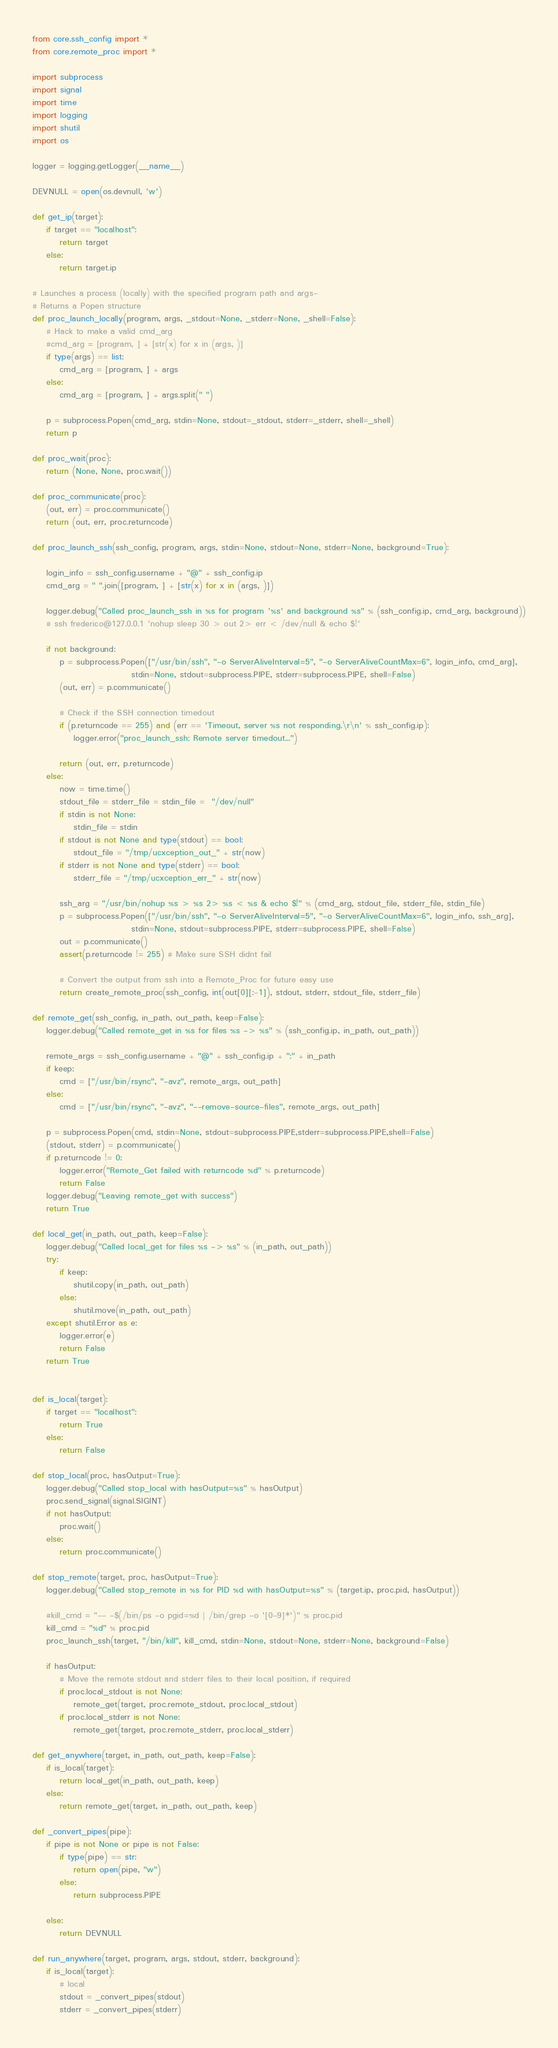Convert code to text. <code><loc_0><loc_0><loc_500><loc_500><_Python_>from core.ssh_config import *
from core.remote_proc import *

import subprocess
import signal
import time
import logging
import shutil
import os

logger = logging.getLogger(__name__)

DEVNULL = open(os.devnull, 'w')

def get_ip(target):
	if target == "localhost":
		return target
	else:
		return target.ip

# Launches a process (locally) with the specified program path and args-
# Returns a Popen structure
def proc_launch_locally(program, args, _stdout=None, _stderr=None, _shell=False):
	# Hack to make a valid cmd_arg
	#cmd_arg = [program, ] + [str(x) for x in (args, )]
	if type(args) == list:
		cmd_arg = [program, ] + args
	else:
		cmd_arg = [program, ] + args.split(" ")

	p = subprocess.Popen(cmd_arg, stdin=None, stdout=_stdout, stderr=_stderr, shell=_shell)
	return p

def proc_wait(proc):
	return (None, None, proc.wait())

def proc_communicate(proc):
	(out, err) = proc.communicate()
	return (out, err, proc.returncode)

def proc_launch_ssh(ssh_config, program, args, stdin=None, stdout=None, stderr=None, background=True):

	login_info = ssh_config.username + "@" + ssh_config.ip 
	cmd_arg = " ".join([program, ] + [str(x) for x in (args, )])
	
	logger.debug("Called proc_launch_ssh in %s for program '%s' and background %s" % (ssh_config.ip, cmd_arg, background))
	# ssh frederico@127.0.0.1 'nohup sleep 30 > out 2> err < /dev/null & echo $!'

	if not background:
		p = subprocess.Popen(["/usr/bin/ssh", "-o ServerAliveInterval=5", "-o ServerAliveCountMax=6", login_info, cmd_arg],
							 stdin=None, stdout=subprocess.PIPE, stderr=subprocess.PIPE, shell=False)
		(out, err) = p.communicate()

		# Check if the SSH connection timedout
		if (p.returncode == 255) and (err == 'Timeout, server %s not responding.\r\n' % ssh_config.ip):
			logger.error("proc_launch_ssh: Remote server timedout...")

		return (out, err, p.returncode)
	else:
		now = time.time()
		stdout_file = stderr_file = stdin_file =  "/dev/null"
		if stdin is not None:
			stdin_file = stdin
		if stdout is not None and type(stdout) == bool:
			stdout_file = "/tmp/ucxception_out_" + str(now)
		if stderr is not None and type(stderr) == bool:
			stderr_file = "/tmp/ucxception_err_" + str(now)

		ssh_arg = "/usr/bin/nohup %s > %s 2> %s < %s & echo $!" % (cmd_arg, stdout_file, stderr_file, stdin_file)
		p = subprocess.Popen(["/usr/bin/ssh", "-o ServerAliveInterval=5", "-o ServerAliveCountMax=6", login_info, ssh_arg],
							 stdin=None, stdout=subprocess.PIPE, stderr=subprocess.PIPE, shell=False)
		out = p.communicate()
		assert(p.returncode != 255) # Make sure SSH didnt fail

		# Convert the output from ssh into a Remote_Proc for future easy use
		return create_remote_proc(ssh_config, int(out[0][:-1]), stdout, stderr, stdout_file, stderr_file)

def remote_get(ssh_config, in_path, out_path, keep=False):
	logger.debug("Called remote_get in %s for files %s -> %s" % (ssh_config.ip, in_path, out_path))

	remote_args = ssh_config.username + "@" + ssh_config.ip + ":" + in_path
	if keep:
		cmd = ["/usr/bin/rsync", "-avz", remote_args, out_path]
	else:
		cmd = ["/usr/bin/rsync", "-avz", "--remove-source-files", remote_args, out_path]

	p = subprocess.Popen(cmd, stdin=None, stdout=subprocess.PIPE,stderr=subprocess.PIPE,shell=False)
	(stdout, stderr) = p.communicate()
	if p.returncode != 0:
		logger.error("Remote_Get failed with returncode %d" % p.returncode)
		return False
	logger.debug("Leaving remote_get with success")
	return True

def local_get(in_path, out_path, keep=False):
	logger.debug("Called local_get for files %s -> %s" % (in_path, out_path))
	try:
		if keep:
			shutil.copy(in_path, out_path)
		else:
			shutil.move(in_path, out_path)
	except shutil.Error as e:
		logger.error(e)
		return False
	return True


def is_local(target):
	if target == "localhost":
		return True
	else:
		return False

def stop_local(proc, hasOutput=True):
	logger.debug("Called stop_local with hasOutput=%s" % hasOutput)
	proc.send_signal(signal.SIGINT)
	if not hasOutput:
		proc.wait()
	else:
		return proc.communicate()

def stop_remote(target, proc, hasOutput=True):
	logger.debug("Called stop_remote in %s for PID %d with hasOutput=%s" % (target.ip, proc.pid, hasOutput))

	#kill_cmd = "-- -$(/bin/ps -o pgid=%d | /bin/grep -o '[0-9]*')" % proc.pid
	kill_cmd = "%d" % proc.pid
	proc_launch_ssh(target, "/bin/kill", kill_cmd, stdin=None, stdout=None, stderr=None, background=False)

	if hasOutput:
		# Move the remote stdout and stderr files to their local position, if required
		if proc.local_stdout is not None:
			remote_get(target, proc.remote_stdout, proc.local_stdout)
		if proc.local_stderr is not None:
			remote_get(target, proc.remote_stderr, proc.local_stderr)

def get_anywhere(target, in_path, out_path, keep=False):
	if is_local(target):
		return local_get(in_path, out_path, keep)
	else:
		return remote_get(target, in_path, out_path, keep)

def _convert_pipes(pipe):
	if pipe is not None or pipe is not False:
		if type(pipe) == str:
			return open(pipe, "w")
		else:
			return subprocess.PIPE

	else:
		return DEVNULL

def run_anywhere(target, program, args, stdout, stderr, background):
	if is_local(target):
		# local
		stdout = _convert_pipes(stdout)
		stderr = _convert_pipes(stderr)
</code> 